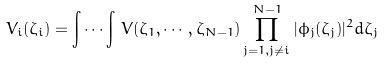<formula> <loc_0><loc_0><loc_500><loc_500>V _ { i } ( \zeta _ { i } ) = \int \cdots \int \, V ( \zeta _ { 1 } , \cdots , \zeta _ { N - 1 } ) \prod _ { j = 1 , j \ne i } ^ { N - 1 } | \phi _ { j } ( \zeta _ { j } ) | ^ { 2 } d \zeta _ { j }</formula> 